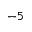<formula> <loc_0><loc_0><loc_500><loc_500>^ { - 5 }</formula> 